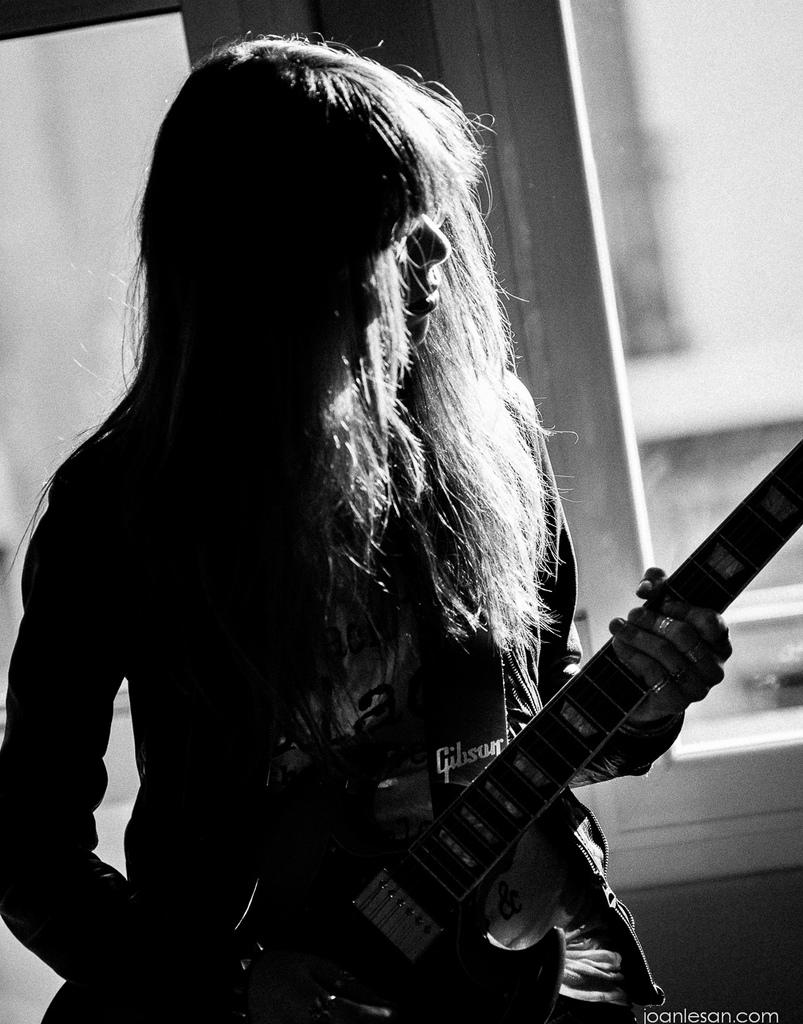Who is present in the image? There is a woman in the image. What is the woman holding in the image? The woman is holding a guitar. What can be seen in the background of the image? There is a window in the background of the image. What type of glove is the woman wearing on her feet in the image? There is no glove or mention of feet in the image; the woman is holding a guitar and standing near a window. 